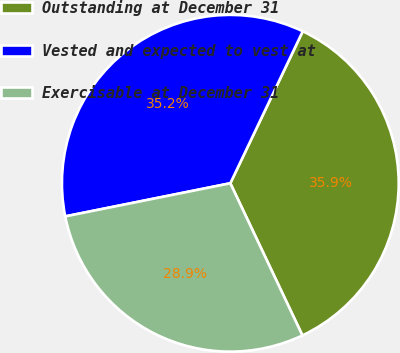Convert chart to OTSL. <chart><loc_0><loc_0><loc_500><loc_500><pie_chart><fcel>Outstanding at December 31<fcel>Vested and expected to vest at<fcel>Exercisable at December 31<nl><fcel>35.88%<fcel>35.23%<fcel>28.89%<nl></chart> 